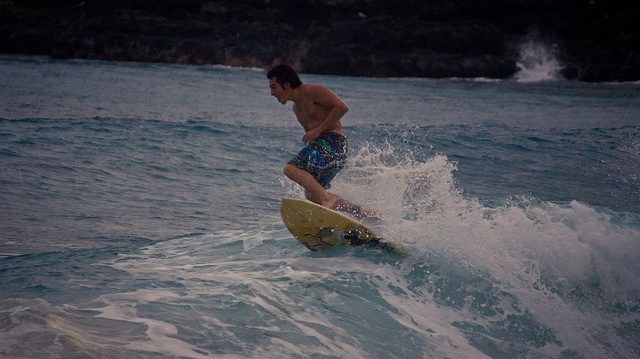Describe the objects in this image and their specific colors. I can see people in black, maroon, gray, and navy tones and surfboard in black and gray tones in this image. 